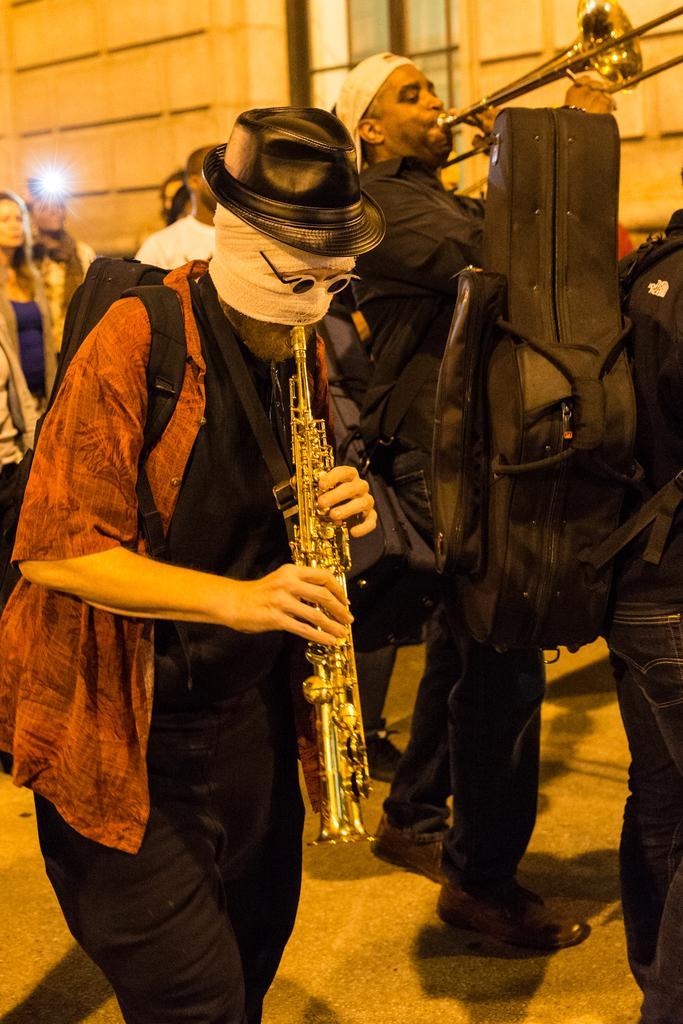Could you give a brief overview of what you see in this image? In this image we can see many people. There are few people playing musical instruments in the image. A person is carrying an object on his back at the right side of the image. 